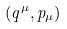Convert formula to latex. <formula><loc_0><loc_0><loc_500><loc_500>( q ^ { \mu } , p _ { \mu } )</formula> 